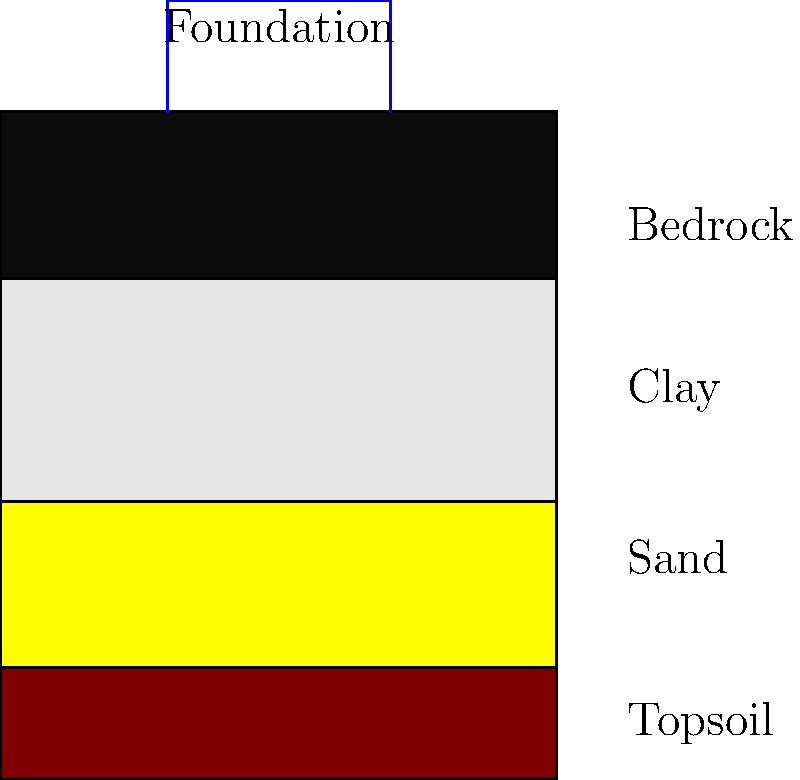In the soil profile shown, which layer would be most suitable for supporting a foundation, and how does this relate to the concept of "grounding" in yoga philosophy? To answer this question, let's analyze the soil layers and their properties:

1. Topsoil: The uppermost layer, typically rich in organic matter. It's unsuitable for foundation support due to its loose structure and potential for settling.

2. Sand: While sand can provide good drainage, it may not offer sufficient bearing capacity for heavy structures.

3. Clay: Clay can be problematic for foundations due to its tendency to expand when wet and shrink when dry, potentially causing structural instability.

4. Bedrock: The bottom layer, bedrock, is the most suitable for supporting a foundation. It provides a solid, stable base that can bear heavy loads without significant settlement.

In yoga philosophy, the concept of "grounding" refers to establishing a strong connection with the earth, creating stability and balance. This parallels the importance of a solid foundation in construction:

- Just as a yogi seeks to ground themselves for stability in their practice, a building needs a stable base to withstand various loads and environmental factors.
- The bedrock layer represents the most "grounded" option, providing unwavering support much like how a strong connection to the earth provides emotional and physical stability in yoga.
- In both yoga and construction, the foundation (whether physical or metaphorical) is crucial for supporting what's built upon it, allowing for growth and expansion without compromising stability.
Answer: Bedrock; both provide stable foundations for growth and stability. 